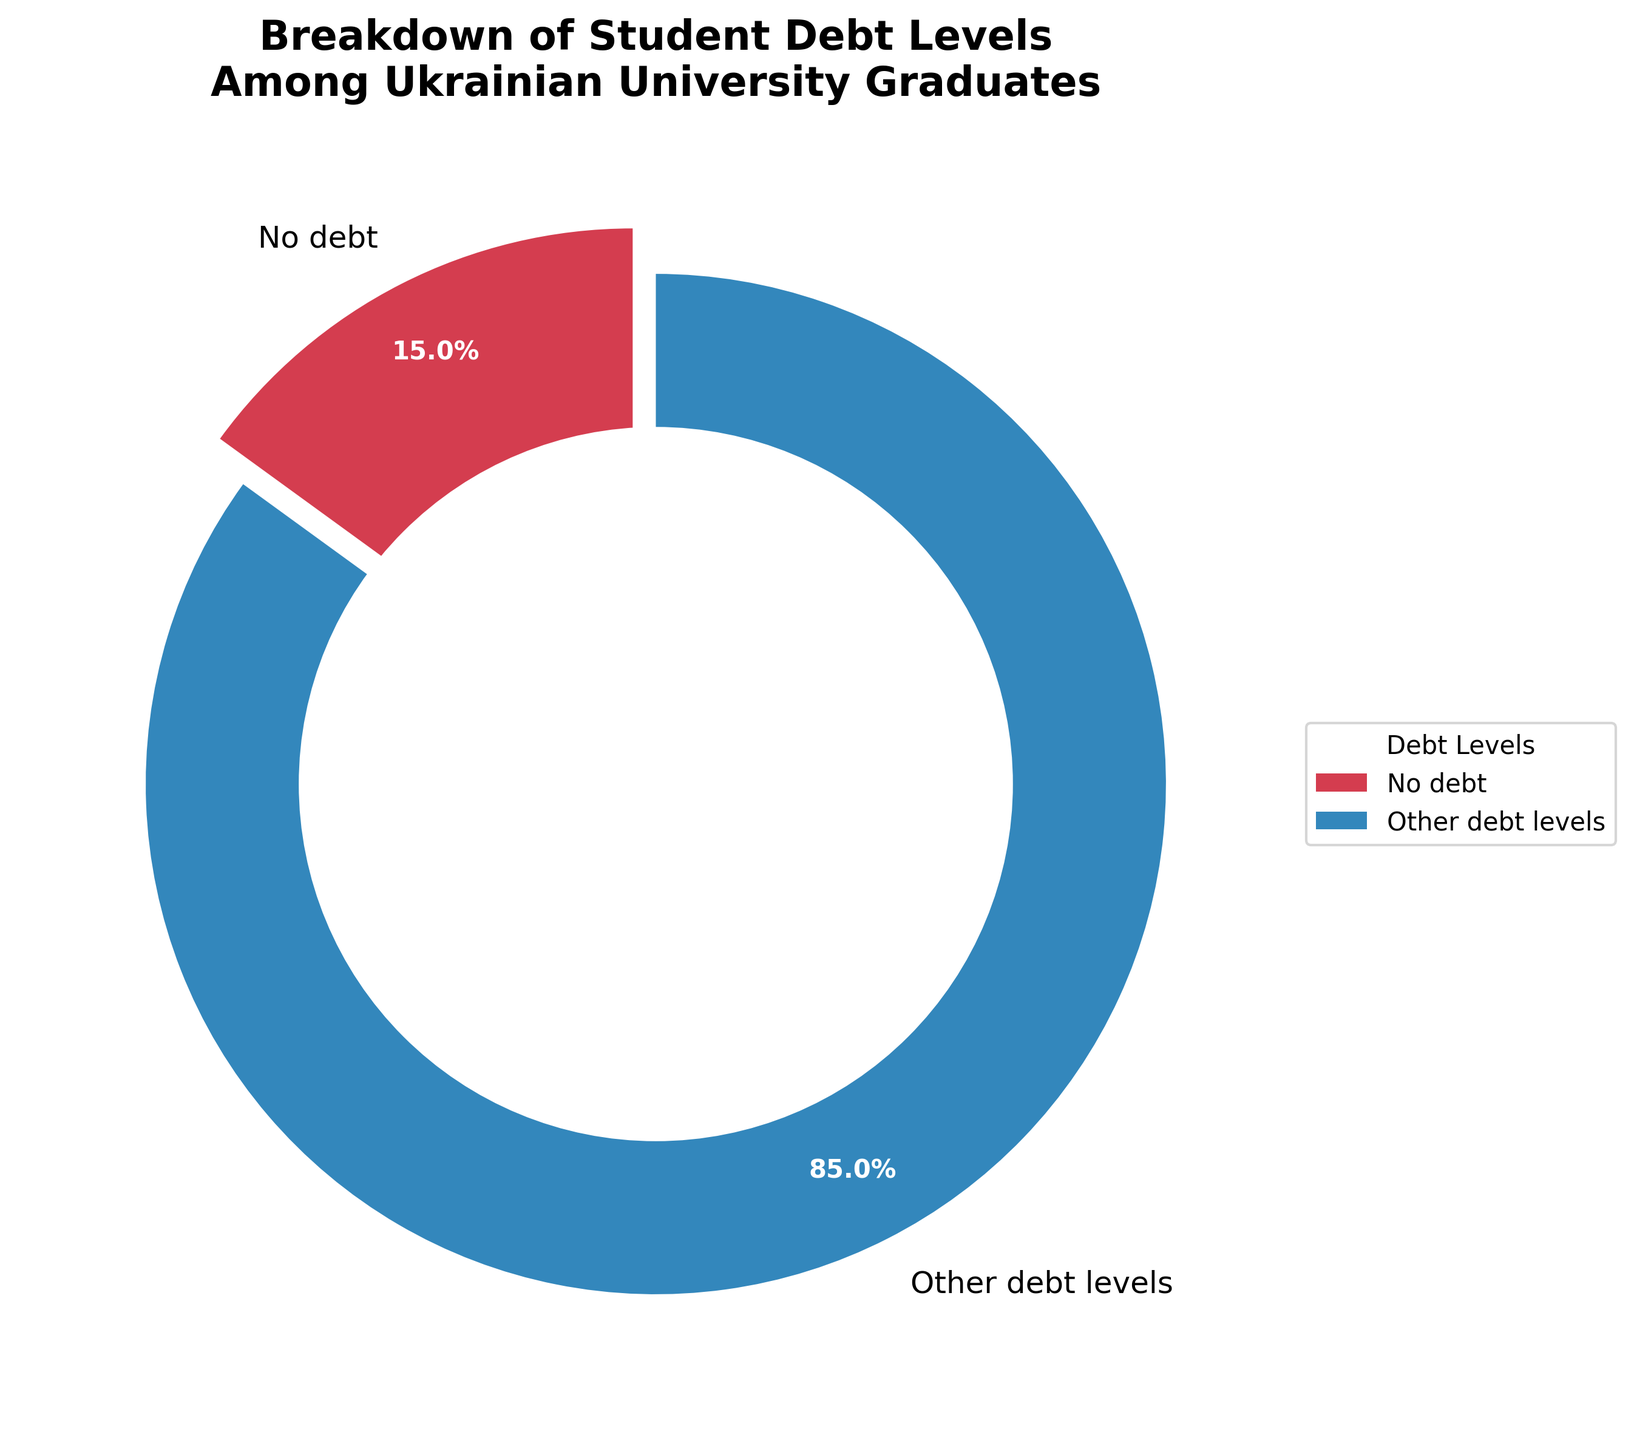What percentage of graduates have no student debt? The pie chart explicitly shows that 15% of graduates have no debt, as indicated by a segment labeled "No debt" with "15.0%" next to it.
Answer: 15% What proportion of the total debt levels does "Other debt levels" represent? The chart adds an additional segment labeled "Other debt levels" calculated by subtracting the sum of known percentages (15% for no debt). This segment thus represents 85% of the total debt levels.
Answer: 85% How does the percentage of graduates with no debt compare to those with debt? According to the chart, 15% of graduates have no debt, and 85% have some form of debt (represented as "Other debt levels"). Comparatively, the percentage of graduates with debt is significantly higher than those without.
Answer: The percentage with debt is higher What is the largest labeled segment in the pie chart? The pie chart visually indicates that the segment labeled "Other debt levels" is the largest, as it covers the majority area compared to the "No debt" segment.
Answer: Other debt levels If the no debt segment were to increase by 5%, what would be the new percentage of "Other debt levels"? If the no debt segment increases by 5%, making it 20%, the "Other debt levels" would decrease by 5% from 85% to 80%, as the sum must always be 100%.
Answer: 80% What color represents the "No debt" segment in the chart? The pie chart utilizes a color scheme where each segment has a distinct color. The specific color for the "No debt" segment can be visually identified in the chart.
Answer: The color of "No debt" (observe chart) What is the difference in percentage points between the no debt and other categories? The difference is calculated by subtracting the percentage of graduates with no debt (15%) from those with other debts (85%), resulting in 70 percentage points.
Answer: 70 percentage points 